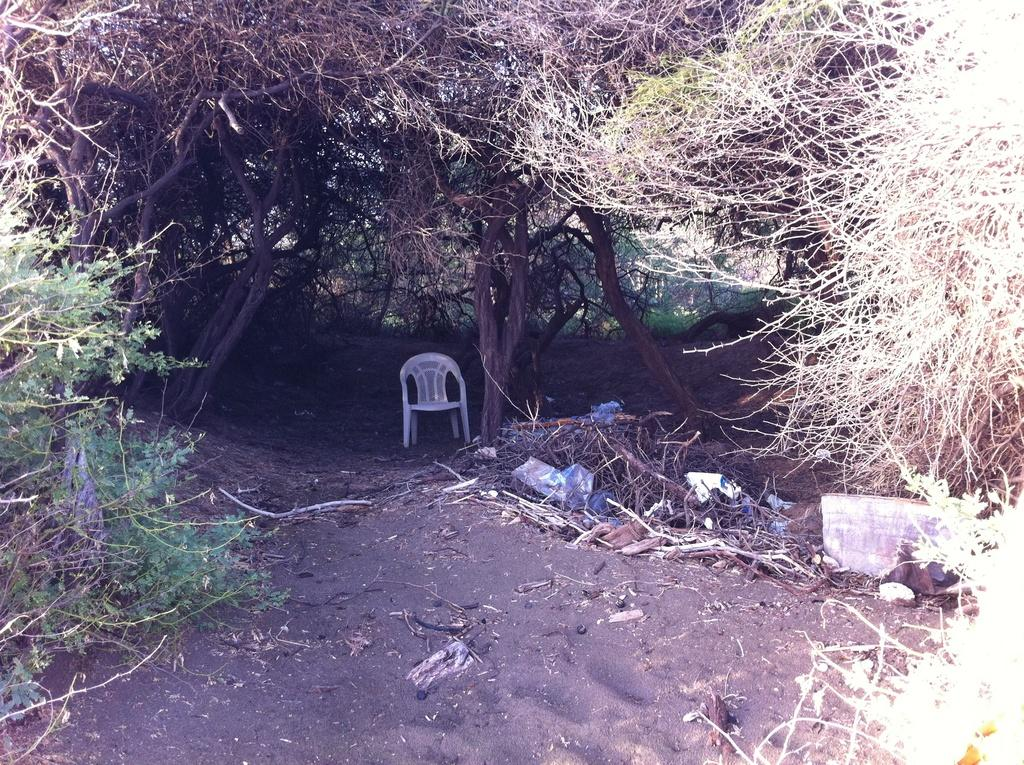What object is on the ground in the image? There is a chair on the ground in the image. What type of objects can be seen in the image? There are sticks and some other objects visible in the image. What can be seen in the distance in the image? There are trees in the background of the image. What type of river can be seen flowing through the drawer in the image? There is no river or drawer present in the image. 